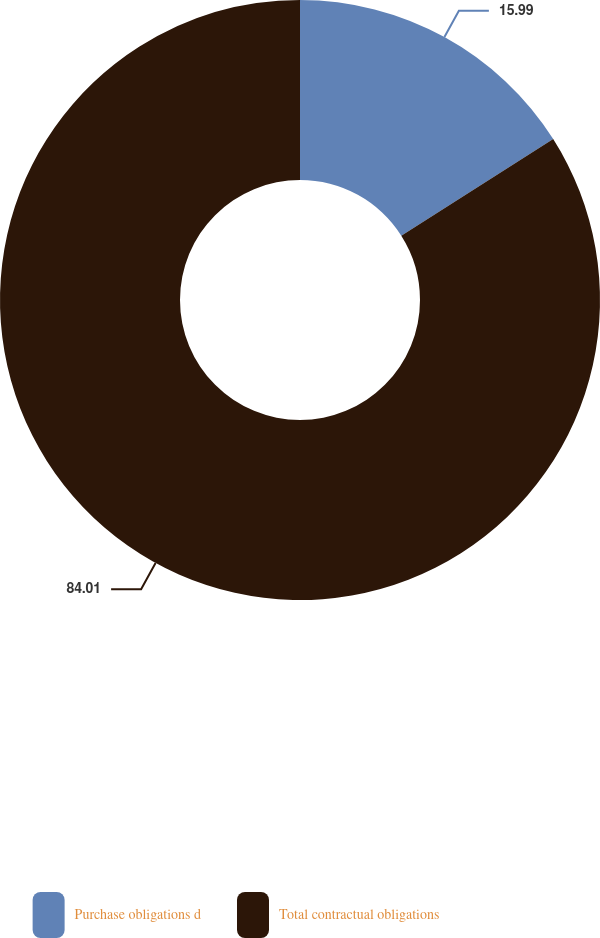Convert chart. <chart><loc_0><loc_0><loc_500><loc_500><pie_chart><fcel>Purchase obligations d<fcel>Total contractual obligations<nl><fcel>15.99%<fcel>84.01%<nl></chart> 